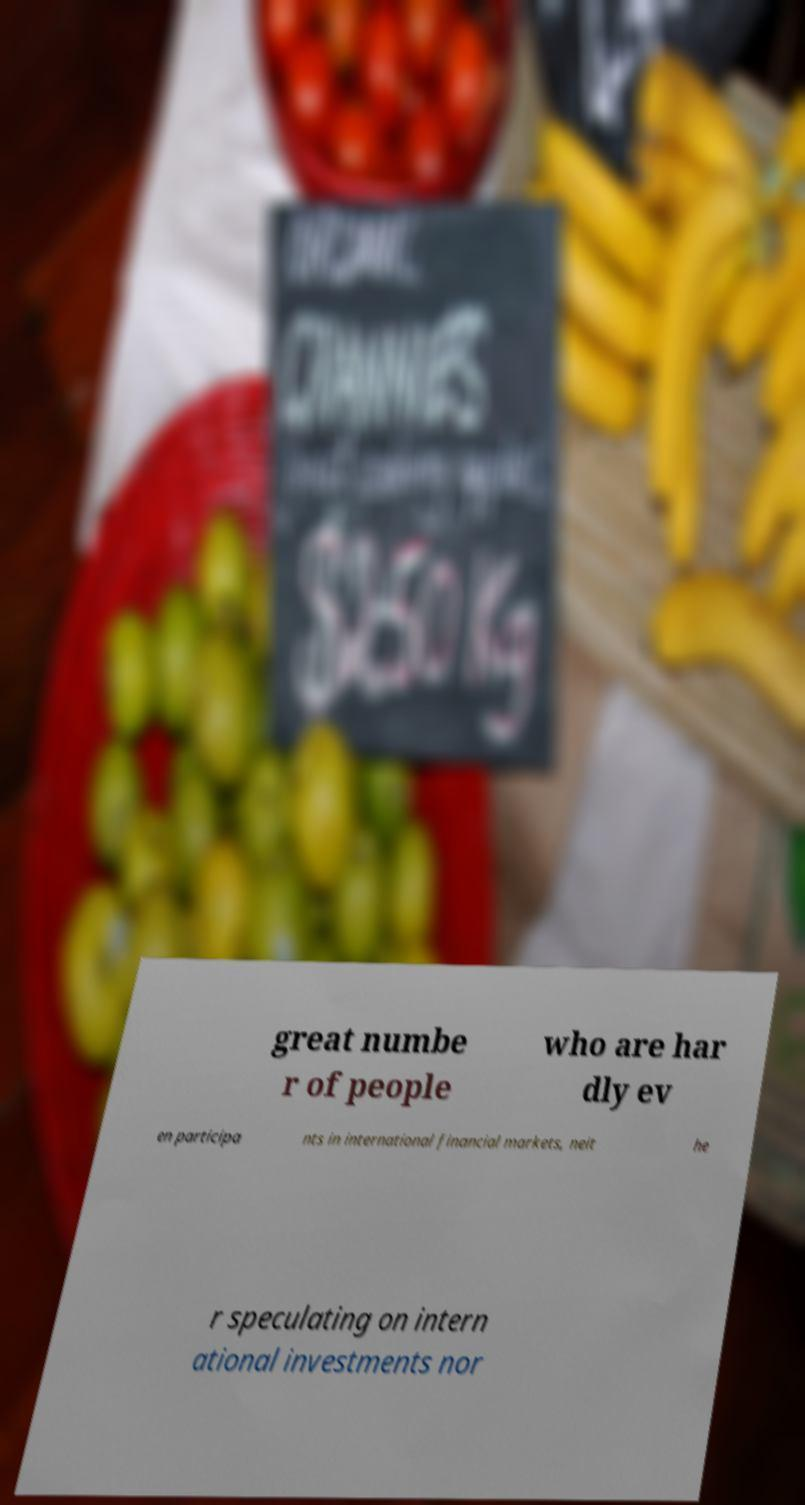I need the written content from this picture converted into text. Can you do that? great numbe r of people who are har dly ev en participa nts in international financial markets, neit he r speculating on intern ational investments nor 